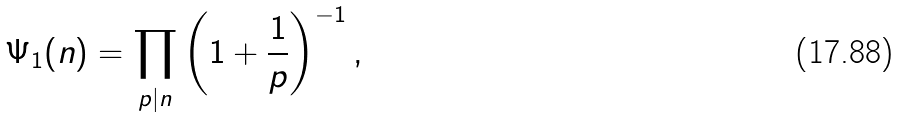Convert formula to latex. <formula><loc_0><loc_0><loc_500><loc_500>\Psi _ { 1 } ( n ) = \prod _ { p | n } \left ( 1 + \frac { 1 } { p } \right ) ^ { - 1 } ,</formula> 